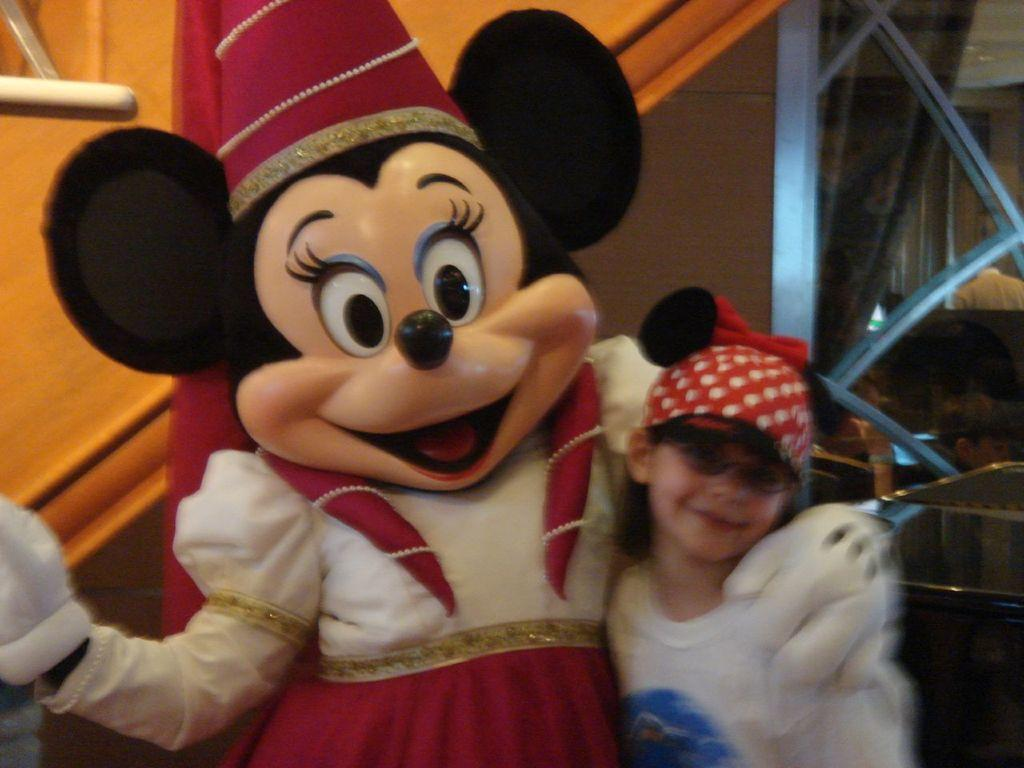Who or what is in the image with the kid? Mickey Mouse is present in the image. What can be seen in the background of the image? There is a wall in the background of the image. How many houses can be seen in the image? There are no houses visible in the image. What type of bird is sitting on Mickey Mouse's shoulder in the image? There is no bird present in the image, let alone on Mickey Mouse's shoulder. 